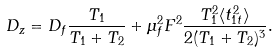Convert formula to latex. <formula><loc_0><loc_0><loc_500><loc_500>D _ { z } = D _ { f } \frac { T _ { 1 } } { T _ { 1 } + T _ { 2 } } + \mu _ { f } ^ { 2 } F ^ { 2 } \frac { T _ { 1 } ^ { 2 } \langle t _ { 1 t } ^ { 2 } \rangle } { 2 ( T _ { 1 } + T _ { 2 } ) ^ { 3 } } .</formula> 